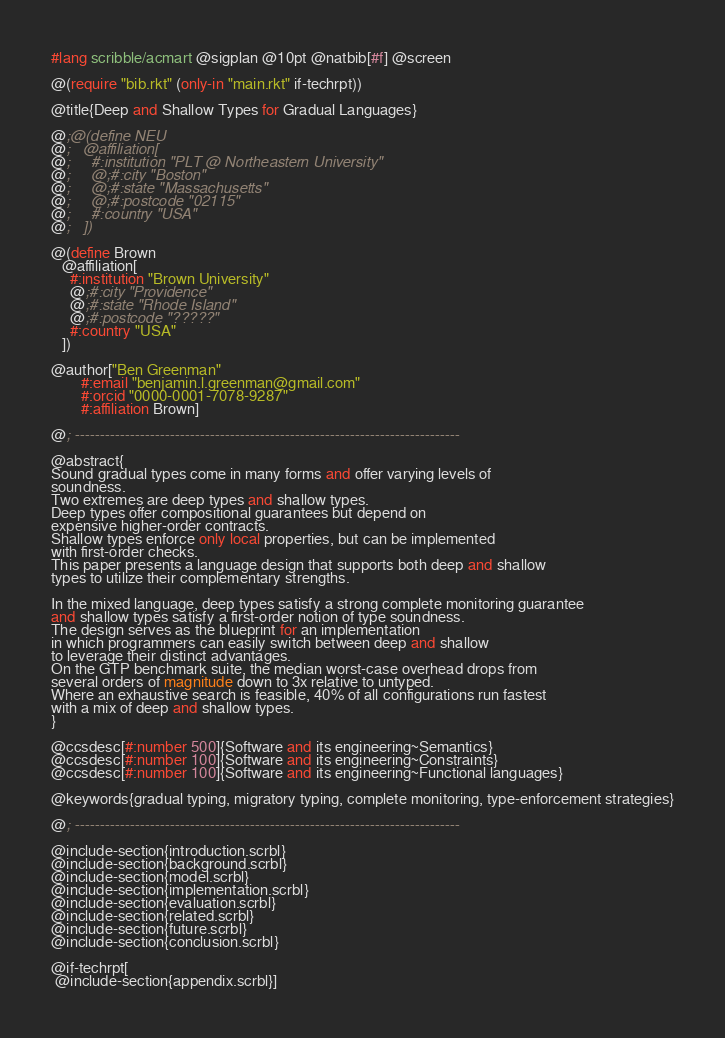Convert code to text. <code><loc_0><loc_0><loc_500><loc_500><_Racket_>#lang scribble/acmart @sigplan @10pt @natbib[#f] @screen

@(require "bib.rkt" (only-in "main.rkt" if-techrpt))

@title{Deep and Shallow Types for Gradual Languages}

@;@(define NEU
@;   @affiliation[
@;     #:institution "PLT @ Northeastern University"
@;     @;#:city "Boston"
@;     @;#:state "Massachusetts"
@;     @;#:postcode "02115"
@;     #:country "USA"
@;   ])

@(define Brown
   @affiliation[
     #:institution "Brown University"
     @;#:city "Providence"
     @;#:state "Rhode Island"
     @;#:postcode "?????"
     #:country "USA"
   ])

@author["Ben Greenman"
        #:email "benjamin.l.greenman@gmail.com"
        #:orcid "0000-0001-7078-9287"
        #:affiliation Brown]

@; -----------------------------------------------------------------------------

@abstract{
Sound gradual types come in many forms and offer varying levels of
soundness.
Two extremes are deep types and shallow types.
Deep types offer compositional guarantees but depend on
expensive higher-order contracts.
Shallow types enforce only local properties, but can be implemented
with first-order checks.
This paper presents a language design that supports both deep and shallow
types to utilize their complementary strengths.

In the mixed language, deep types satisfy a strong complete monitoring guarantee
and shallow types satisfy a first-order notion of type soundness.
The design serves as the blueprint for an implementation
in which programmers can easily switch between deep and shallow
to leverage their distinct advantages.
On the GTP benchmark suite, the median worst-case overhead drops from
several orders of magnitude down to 3x relative to untyped.
Where an exhaustive search is feasible, 40% of all configurations run fastest
with a mix of deep and shallow types.
}

@ccsdesc[#:number 500]{Software and its engineering~Semantics}
@ccsdesc[#:number 100]{Software and its engineering~Constraints}
@ccsdesc[#:number 100]{Software and its engineering~Functional languages}

@keywords{gradual typing, migratory typing, complete monitoring, type-enforcement strategies}

@; -----------------------------------------------------------------------------

@include-section{introduction.scrbl}
@include-section{background.scrbl}
@include-section{model.scrbl}
@include-section{implementation.scrbl}
@include-section{evaluation.scrbl}
@include-section{related.scrbl}
@include-section{future.scrbl}
@include-section{conclusion.scrbl}

@if-techrpt[
 @include-section{appendix.scrbl}]

</code> 